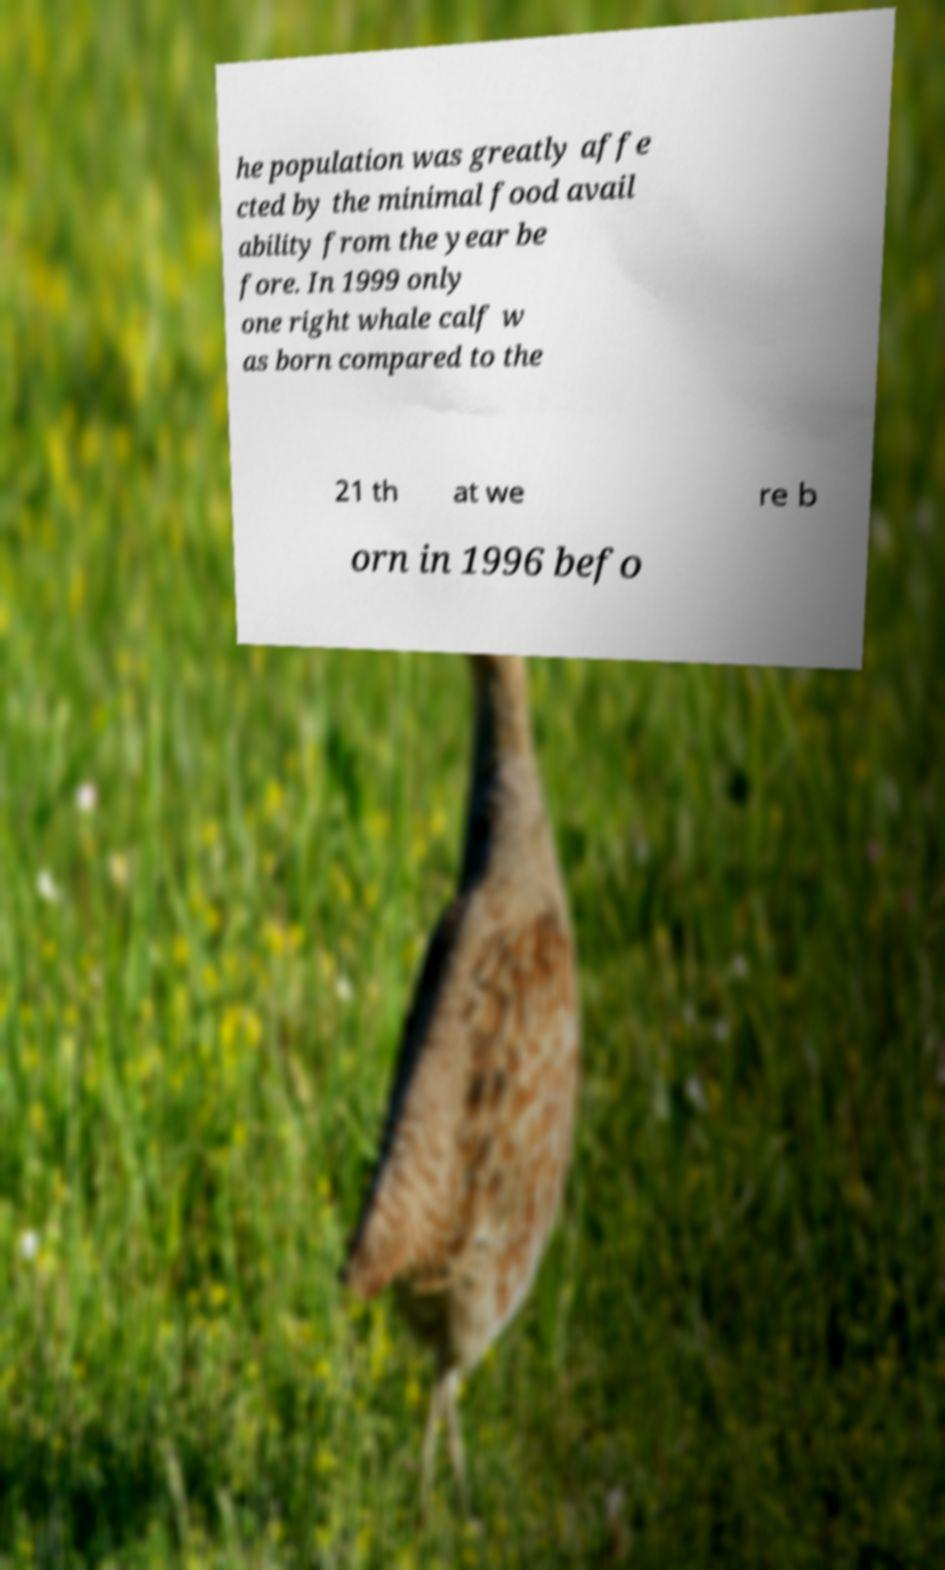Can you read and provide the text displayed in the image?This photo seems to have some interesting text. Can you extract and type it out for me? he population was greatly affe cted by the minimal food avail ability from the year be fore. In 1999 only one right whale calf w as born compared to the 21 th at we re b orn in 1996 befo 